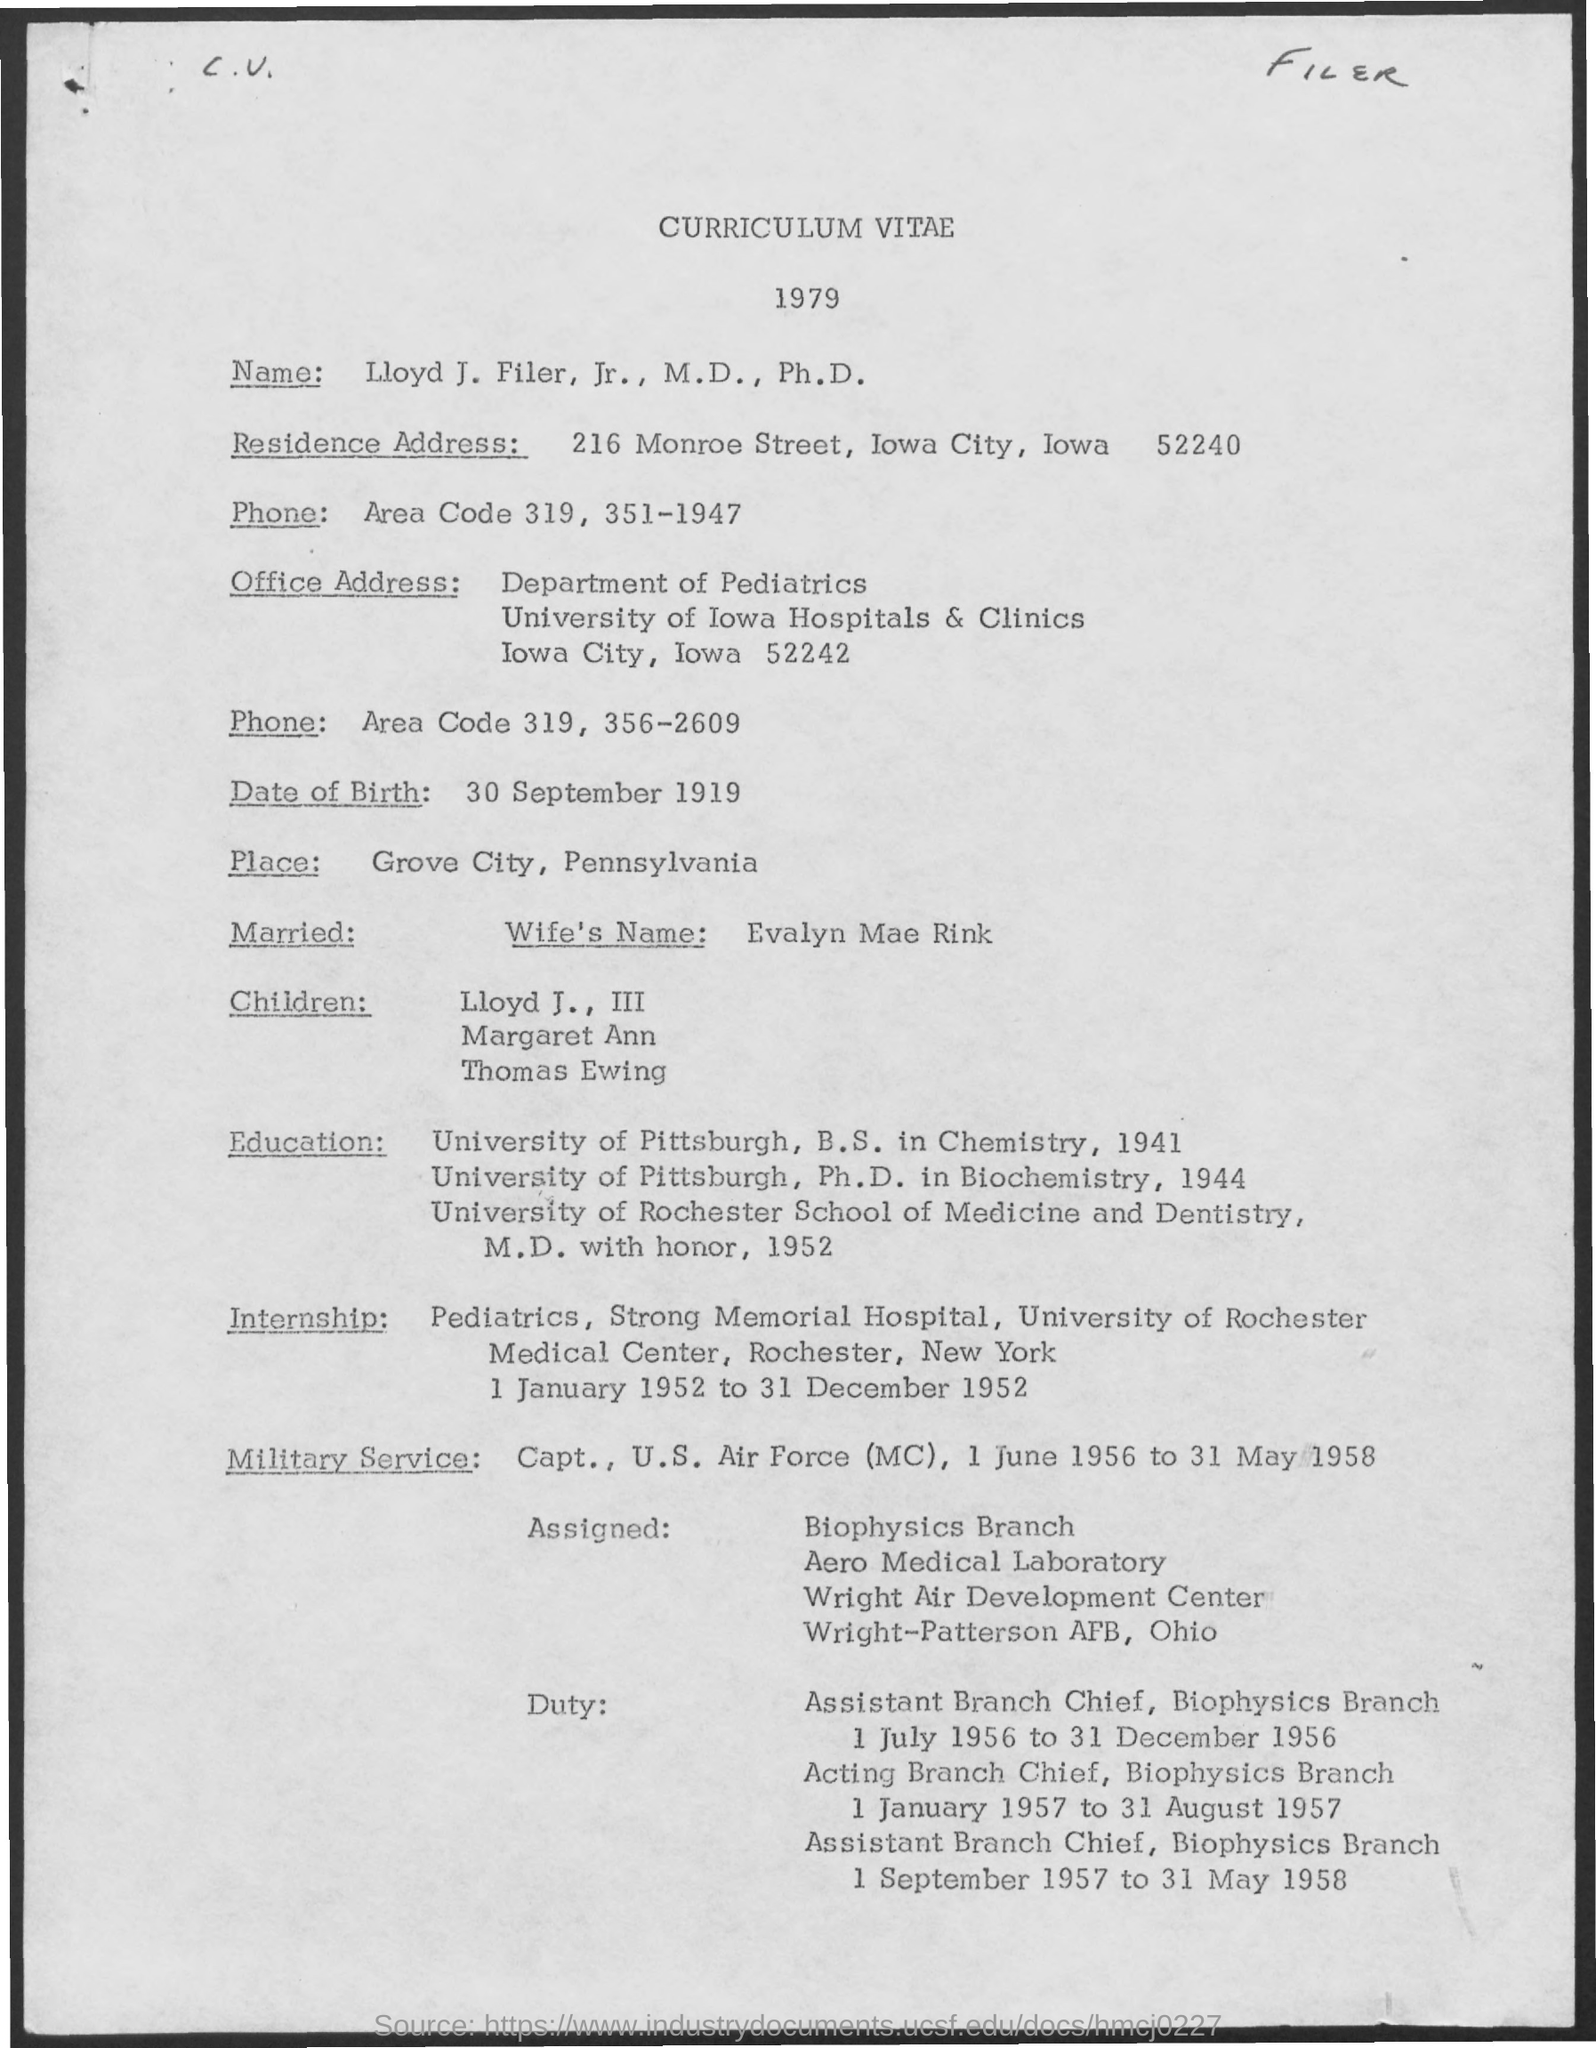Give some essential details in this illustration. The document is about a curriculum vitae. The name of the wife is Evalyn Mae Rink. The address is 216 Monroe Street in Iowa City, Iowa 52240. Curriculum Vitae was created in 1979. Whose Curriculum Vitae is it? It belongs to Lloyd J. Filer. 